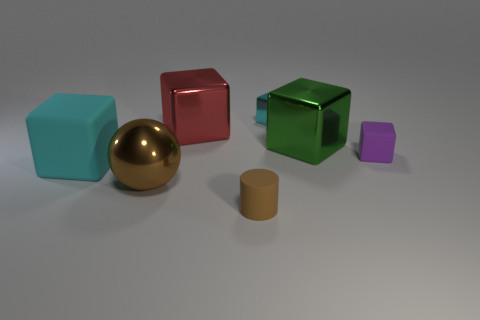What is the shape of the big green object?
Your response must be concise. Cube. There is a cube that is the same color as the large rubber object; what size is it?
Ensure brevity in your answer.  Small. There is a small cube that is the same material as the big brown sphere; what is its color?
Provide a short and direct response. Cyan. Does the small purple object have the same material as the big object on the right side of the tiny cyan metallic cube?
Your response must be concise. No. The rubber cylinder has what color?
Your answer should be very brief. Brown. What is the size of the green block that is the same material as the large brown thing?
Your answer should be very brief. Large. What number of rubber objects are behind the cyan cube to the right of the matte object in front of the brown ball?
Give a very brief answer. 0. Do the large ball and the small thing to the left of the cyan shiny cube have the same color?
Your answer should be compact. Yes. There is a rubber object that is the same color as the shiny sphere; what is its shape?
Provide a succinct answer. Cylinder. What material is the cyan block that is behind the shiny cube right of the cyan shiny block behind the small brown cylinder?
Your answer should be compact. Metal. 